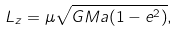<formula> <loc_0><loc_0><loc_500><loc_500>L _ { z } = \mu \sqrt { G M a ( 1 - e ^ { 2 } ) } ,</formula> 